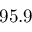Convert formula to latex. <formula><loc_0><loc_0><loc_500><loc_500>9 5 . 9</formula> 